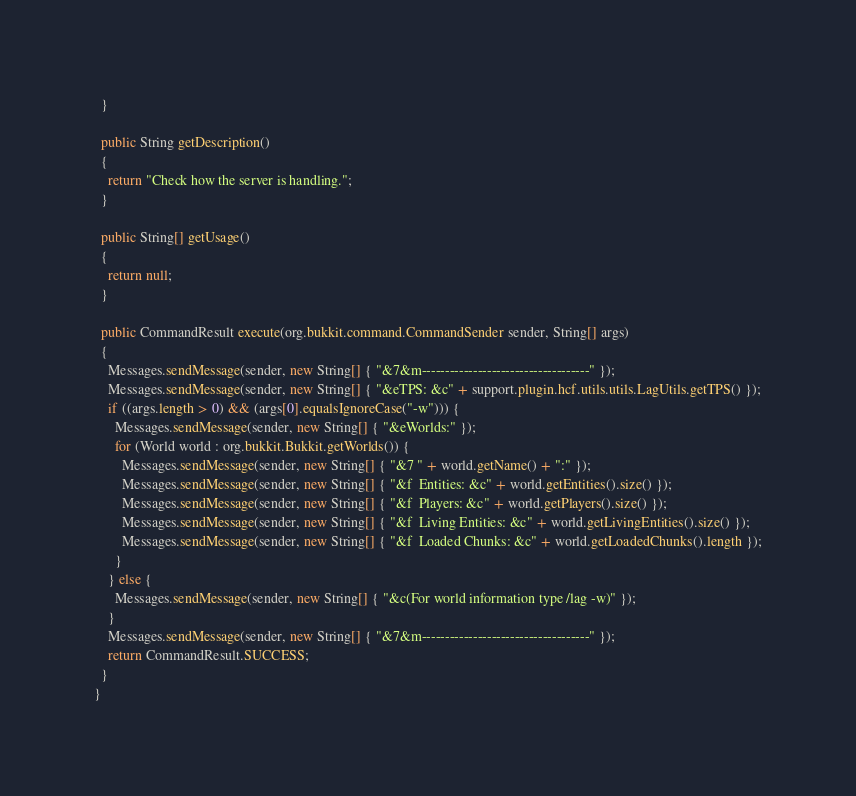Convert code to text. <code><loc_0><loc_0><loc_500><loc_500><_Java_>  }
  
  public String getDescription()
  {
    return "Check how the server is handling.";
  }
  
  public String[] getUsage()
  {
    return null;
  }
  
  public CommandResult execute(org.bukkit.command.CommandSender sender, String[] args)
  {
    Messages.sendMessage(sender, new String[] { "&7&m------------------------------------" });
    Messages.sendMessage(sender, new String[] { "&eTPS: &c" + support.plugin.hcf.utils.utils.LagUtils.getTPS() });
    if ((args.length > 0) && (args[0].equalsIgnoreCase("-w"))) {
      Messages.sendMessage(sender, new String[] { "&eWorlds:" });
      for (World world : org.bukkit.Bukkit.getWorlds()) {
        Messages.sendMessage(sender, new String[] { "&7 " + world.getName() + ":" });
        Messages.sendMessage(sender, new String[] { "&f  Entities: &c" + world.getEntities().size() });
        Messages.sendMessage(sender, new String[] { "&f  Players: &c" + world.getPlayers().size() });
        Messages.sendMessage(sender, new String[] { "&f  Living Entities: &c" + world.getLivingEntities().size() });
        Messages.sendMessage(sender, new String[] { "&f  Loaded Chunks: &c" + world.getLoadedChunks().length });
      }
    } else {
      Messages.sendMessage(sender, new String[] { "&c(For world information type /lag -w)" });
    }
    Messages.sendMessage(sender, new String[] { "&7&m------------------------------------" });
    return CommandResult.SUCCESS;
  }
}
</code> 